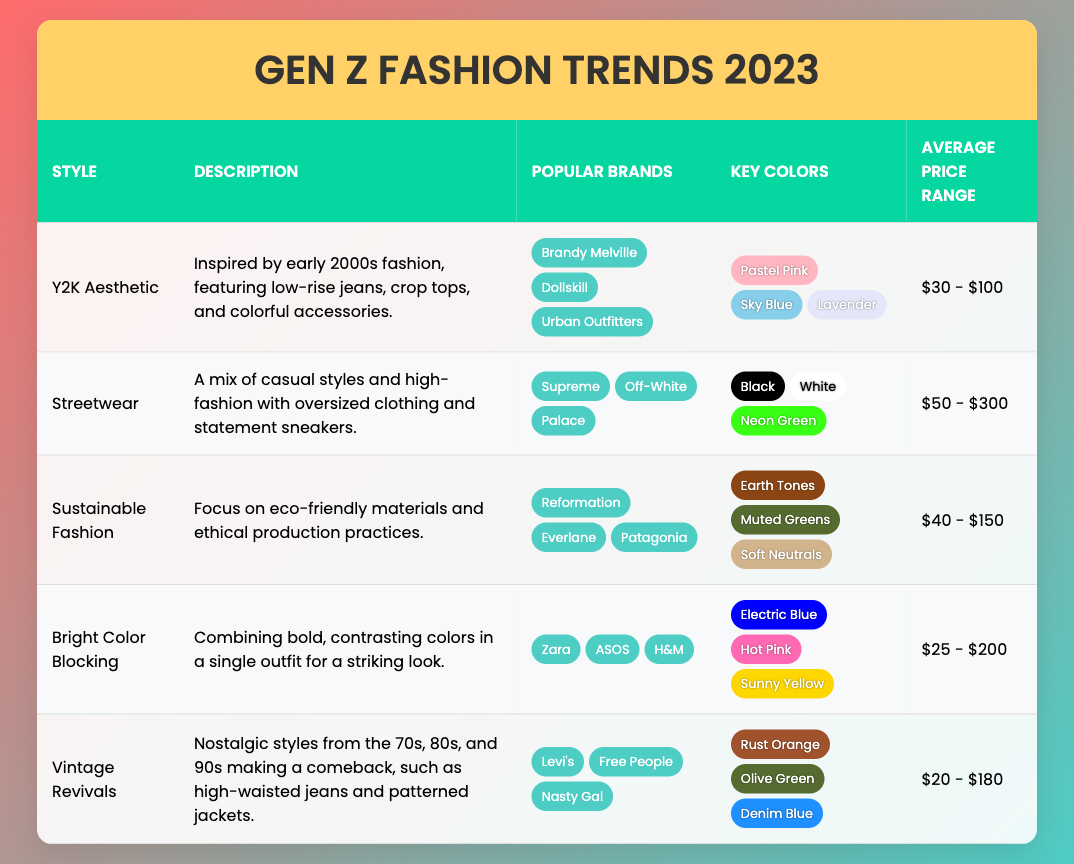What's the average price range for the Y2K Aesthetic style? The average price range for the Y2K Aesthetic style is listed as $30 - $100 directly in the table under the corresponding column.
Answer: $30 - $100 Are there any styles that use Earth Tones as a key color? By scanning the table, it is found that the Sustainable Fashion style uses Earth Tones as a key color, while Vintage Revivals also features Olive Green. Therefore, the answer is yes.
Answer: Yes What is the total number of brands listed under the Bright Color Blocking style? The table shows three brands listed under the Bright Color Blocking style: Zara, ASOS, and H&M. Therefore, the total number of brands is counted directly from this list.
Answer: 3 If you combine the average price ranges of Y2K Aesthetic and Vintage Revivals, what would be the total range? The average price range for Y2K Aesthetic is $30 - $100 and for Vintage Revivals is $20 - $180. The total range is calculated by finding the lowest value ($20) and the highest value ($180). The combined average price range is therefore $20 - $180.
Answer: $20 - $180 Which styles are brand-focused and list the popular brands for each? By examining the table for styles that are brand-focused, three styles can be found: Y2K Aesthetic with its brands (Brandy Melville, Dollskill, Urban Outfitters), Streetwear (Supreme, Off-White, Palace), and Sustainable Fashion (Reformation, Everlane, Patagonia).
Answer: Y2K Aesthetic, Streetwear, Sustainable Fashion Do all styles listed incorporate bold colors? The Bold colors may not be represented in all styles. Upon reviewing the table, the styles Bright Color Blocking and Streetwear definitely use bold colors, while Sustainable Fashion focuses more on Earth Tones. Therefore, not all styles incorporate bold colors.
Answer: No Which style features patterns from nostalgic decades? The Vintage Revivals style is highlighted in the table for featuring patterns from nostalgic decades of the 70s, 80s, and 90s, mentioning particular trends such as high-waisted jeans and patterned jackets.
Answer: Vintage Revivals What percentage of styles listed in the table emphasize sustainability? There are five styles in total, and Sustainable Fashion is the only one that specifically emphasizes sustainability. To find the percentage, calculate (1/5) * 100, resulting in 20%.
Answer: 20% 